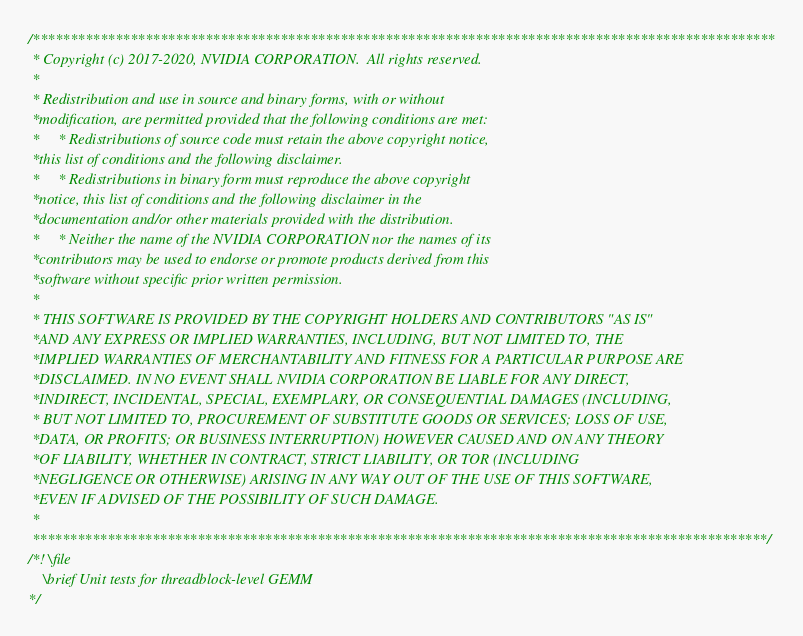Convert code to text. <code><loc_0><loc_0><loc_500><loc_500><_Cuda_>/***************************************************************************************************
 * Copyright (c) 2017-2020, NVIDIA CORPORATION.  All rights reserved.
 *
 * Redistribution and use in source and binary forms, with or without
 *modification, are permitted provided that the following conditions are met:
 *     * Redistributions of source code must retain the above copyright notice,
 *this list of conditions and the following disclaimer.
 *     * Redistributions in binary form must reproduce the above copyright
 *notice, this list of conditions and the following disclaimer in the
 *documentation and/or other materials provided with the distribution.
 *     * Neither the name of the NVIDIA CORPORATION nor the names of its
 *contributors may be used to endorse or promote products derived from this
 *software without specific prior written permission.
 *
 * THIS SOFTWARE IS PROVIDED BY THE COPYRIGHT HOLDERS AND CONTRIBUTORS "AS IS"
 *AND ANY EXPRESS OR IMPLIED WARRANTIES, INCLUDING, BUT NOT LIMITED TO, THE
 *IMPLIED WARRANTIES OF MERCHANTABILITY AND FITNESS FOR A PARTICULAR PURPOSE ARE
 *DISCLAIMED. IN NO EVENT SHALL NVIDIA CORPORATION BE LIABLE FOR ANY DIRECT,
 *INDIRECT, INCIDENTAL, SPECIAL, EXEMPLARY, OR CONSEQUENTIAL DAMAGES (INCLUDING,
 * BUT NOT LIMITED TO, PROCUREMENT OF SUBSTITUTE GOODS OR SERVICES; LOSS OF USE,
 *DATA, OR PROFITS; OR BUSINESS INTERRUPTION) HOWEVER CAUSED AND ON ANY THEORY
 *OF LIABILITY, WHETHER IN CONTRACT, STRICT LIABILITY, OR TOR (INCLUDING
 *NEGLIGENCE OR OTHERWISE) ARISING IN ANY WAY OUT OF THE USE OF THIS SOFTWARE,
 *EVEN IF ADVISED OF THE POSSIBILITY OF SUCH DAMAGE.
 *
 **************************************************************************************************/
/*! \file
    \brief Unit tests for threadblock-level GEMM
*/
</code> 